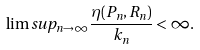<formula> <loc_0><loc_0><loc_500><loc_500>\lim s u p _ { n \rightarrow \infty } \frac { \eta ( P _ { n } , R _ { n } ) } { k _ { n } } < \infty .</formula> 